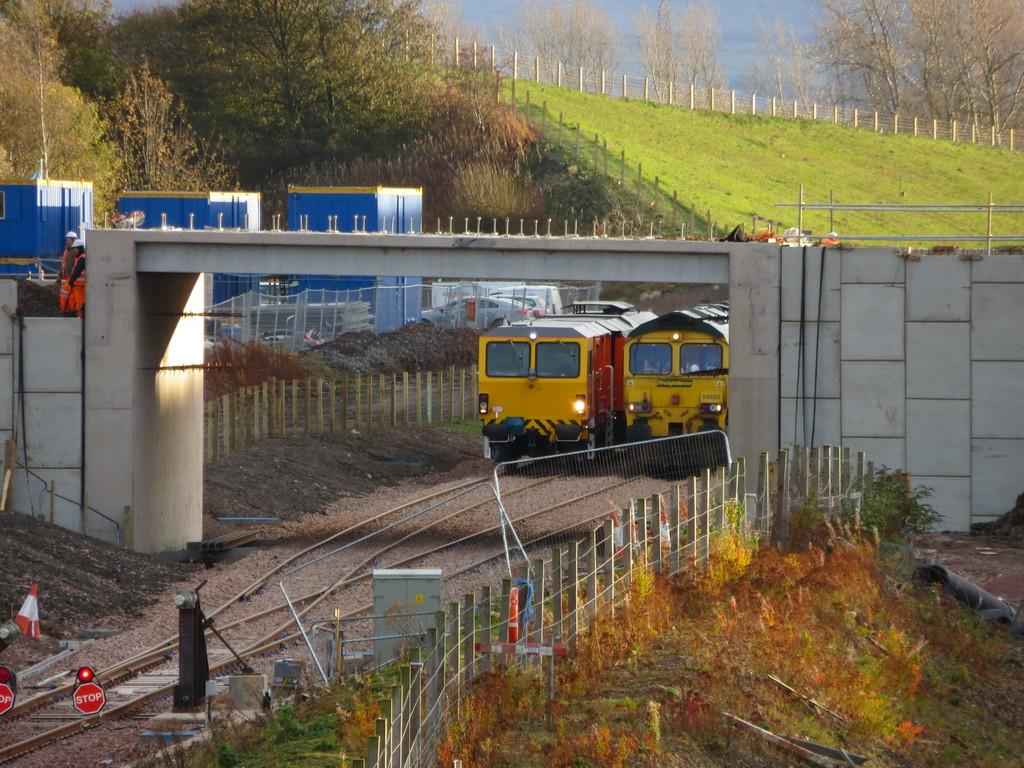What type of vehicles can be seen in the image? Vehicles are visible in the image. What structures are present in the image? There are train tracks, a bridge, and fences visible in the image. What objects are present in the image? Containers and objects are present in the image. What type of plants can be seen in the image? Plants are visible in the image. What natural elements are visible in the background of the image? Trees, grass, and fences are visible in the background of the image. Are there any people present in the image? Yes, there are people in the image. How does the grandfather interact with the cable in the image? There is no grandfather or cable present in the image. What is the distribution of the objects in the image? The distribution of objects in the image cannot be determined without more specific information about their arrangement. 